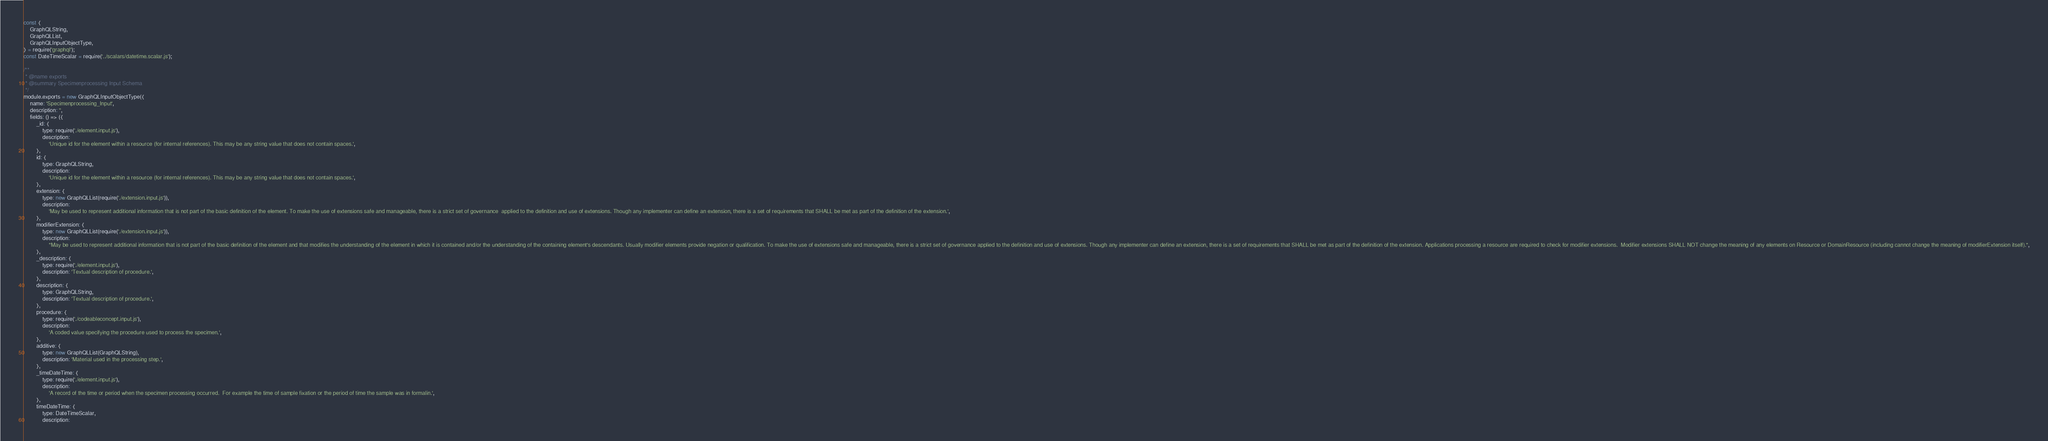<code> <loc_0><loc_0><loc_500><loc_500><_JavaScript_>const {
	GraphQLString,
	GraphQLList,
	GraphQLInputObjectType,
} = require('graphql');
const DateTimeScalar = require('../scalars/datetime.scalar.js');

/**
 * @name exports
 * @summary Specimenprocessing Input Schema
 */
module.exports = new GraphQLInputObjectType({
	name: 'Specimenprocessing_Input',
	description: '',
	fields: () => ({
		_id: {
			type: require('./element.input.js'),
			description:
				'Unique id for the element within a resource (for internal references). This may be any string value that does not contain spaces.',
		},
		id: {
			type: GraphQLString,
			description:
				'Unique id for the element within a resource (for internal references). This may be any string value that does not contain spaces.',
		},
		extension: {
			type: new GraphQLList(require('./extension.input.js')),
			description:
				'May be used to represent additional information that is not part of the basic definition of the element. To make the use of extensions safe and manageable, there is a strict set of governance  applied to the definition and use of extensions. Though any implementer can define an extension, there is a set of requirements that SHALL be met as part of the definition of the extension.',
		},
		modifierExtension: {
			type: new GraphQLList(require('./extension.input.js')),
			description:
				"May be used to represent additional information that is not part of the basic definition of the element and that modifies the understanding of the element in which it is contained and/or the understanding of the containing element's descendants. Usually modifier elements provide negation or qualification. To make the use of extensions safe and manageable, there is a strict set of governance applied to the definition and use of extensions. Though any implementer can define an extension, there is a set of requirements that SHALL be met as part of the definition of the extension. Applications processing a resource are required to check for modifier extensions.  Modifier extensions SHALL NOT change the meaning of any elements on Resource or DomainResource (including cannot change the meaning of modifierExtension itself).",
		},
		_description: {
			type: require('./element.input.js'),
			description: 'Textual description of procedure.',
		},
		description: {
			type: GraphQLString,
			description: 'Textual description of procedure.',
		},
		procedure: {
			type: require('./codeableconcept.input.js'),
			description:
				'A coded value specifying the procedure used to process the specimen.',
		},
		additive: {
			type: new GraphQLList(GraphQLString),
			description: 'Material used in the processing step.',
		},
		_timeDateTime: {
			type: require('./element.input.js'),
			description:
				'A record of the time or period when the specimen processing occurred.  For example the time of sample fixation or the period of time the sample was in formalin.',
		},
		timeDateTime: {
			type: DateTimeScalar,
			description:</code> 